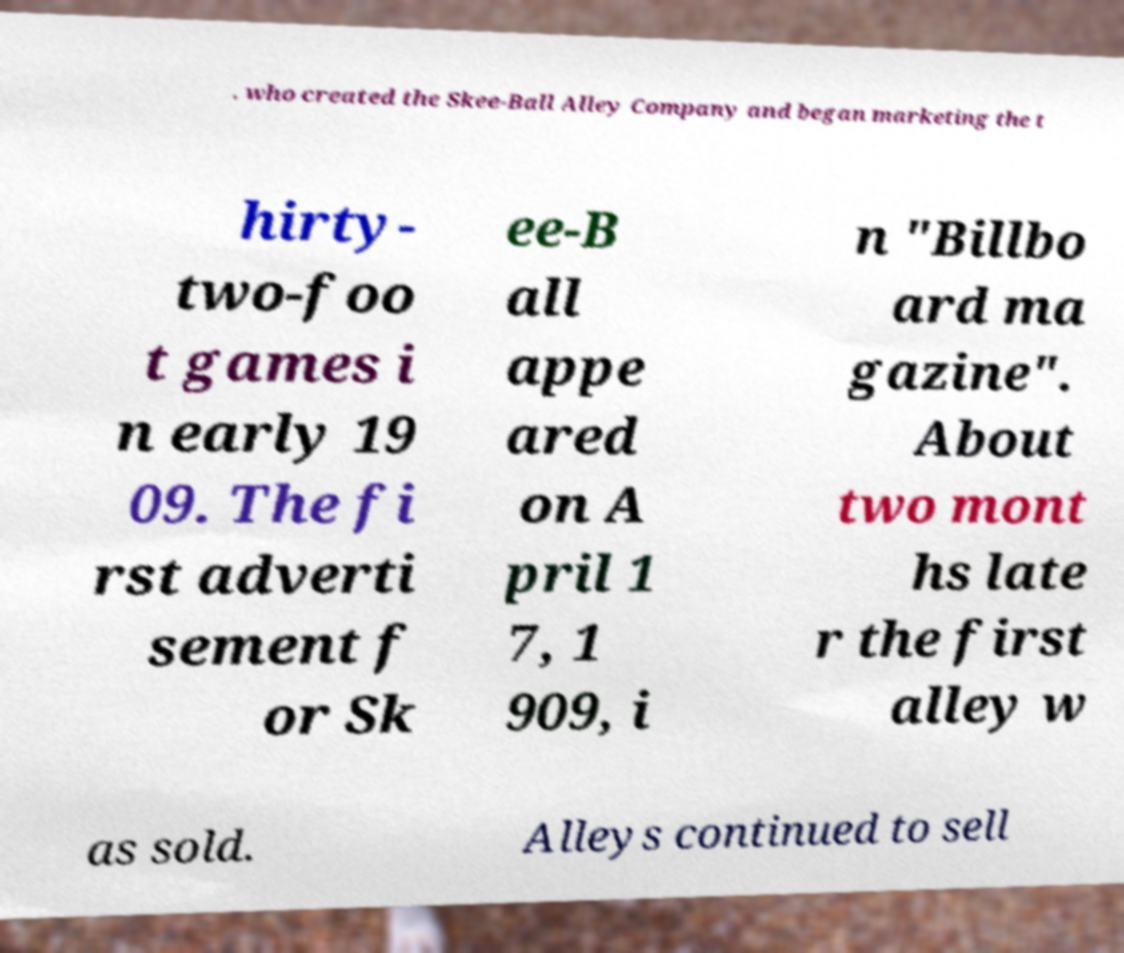Could you assist in decoding the text presented in this image and type it out clearly? . who created the Skee-Ball Alley Company and began marketing the t hirty- two-foo t games i n early 19 09. The fi rst adverti sement f or Sk ee-B all appe ared on A pril 1 7, 1 909, i n "Billbo ard ma gazine". About two mont hs late r the first alley w as sold. Alleys continued to sell 